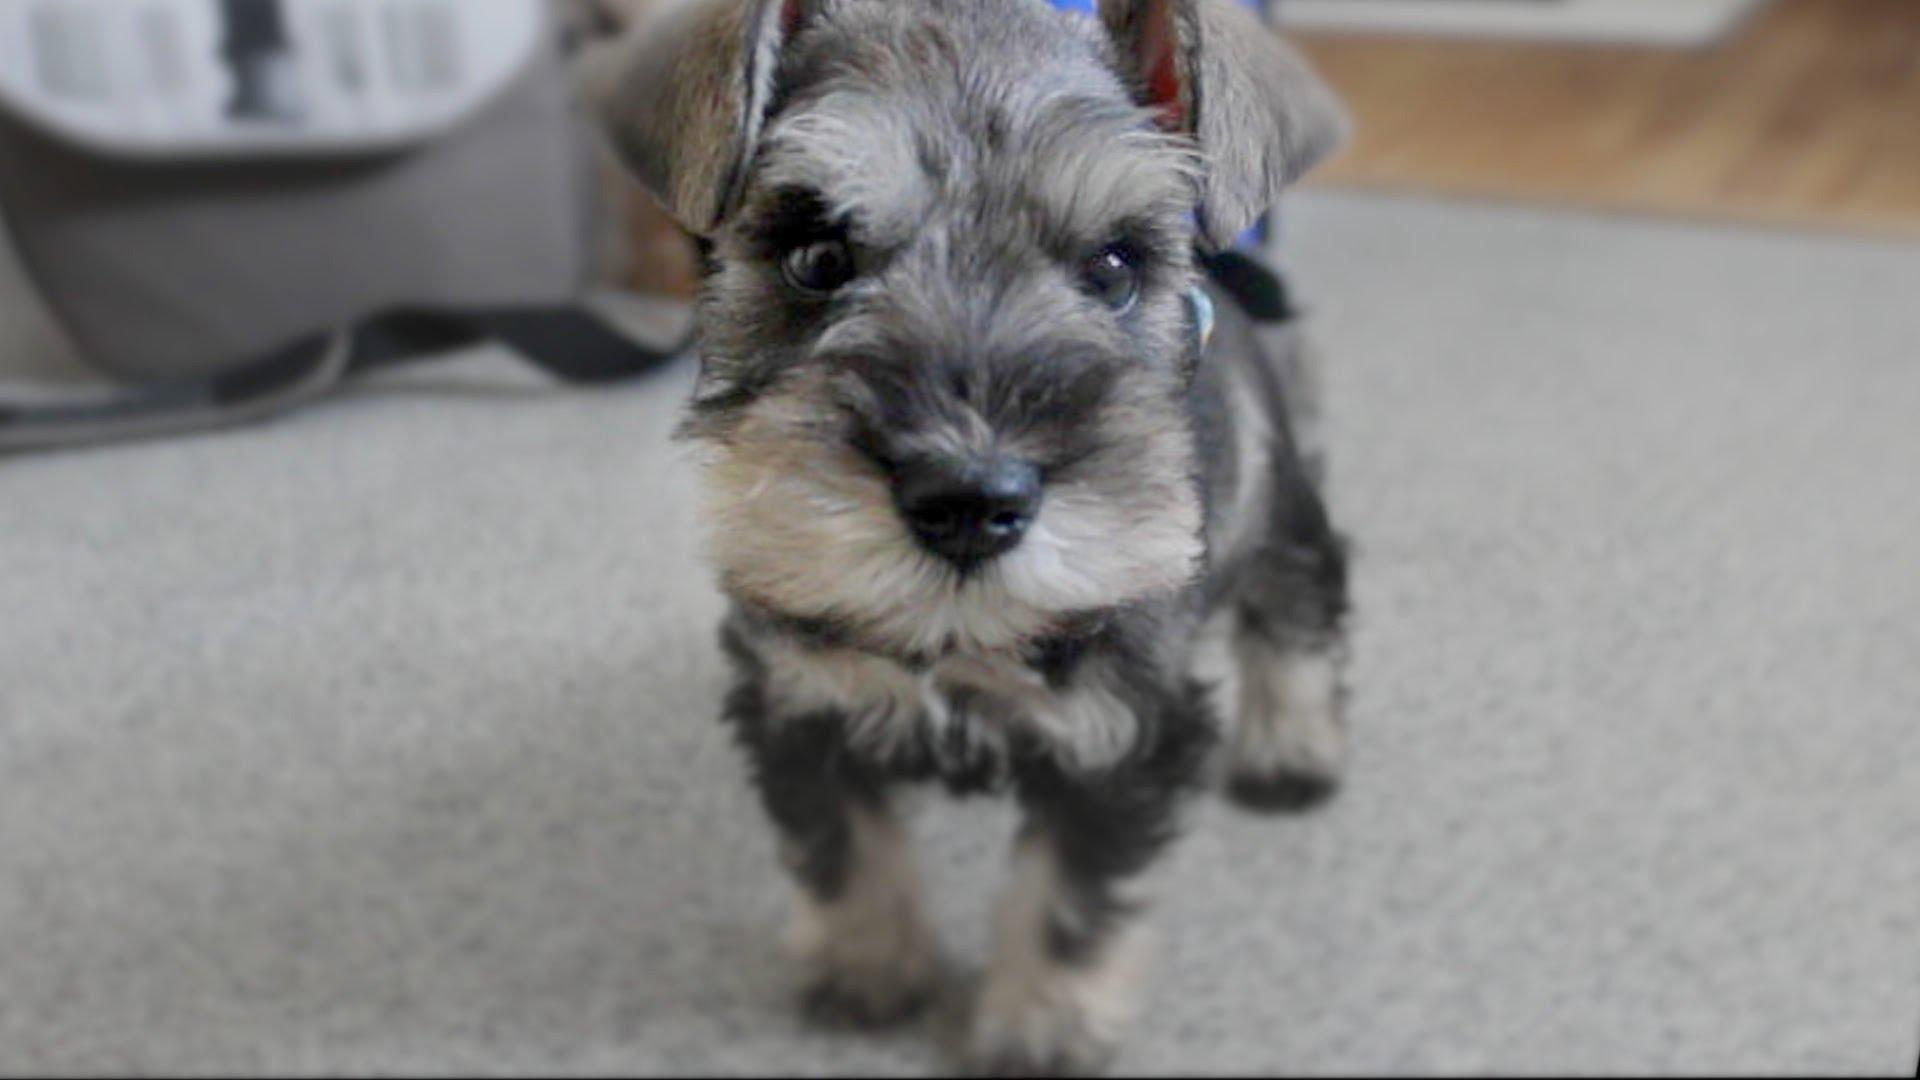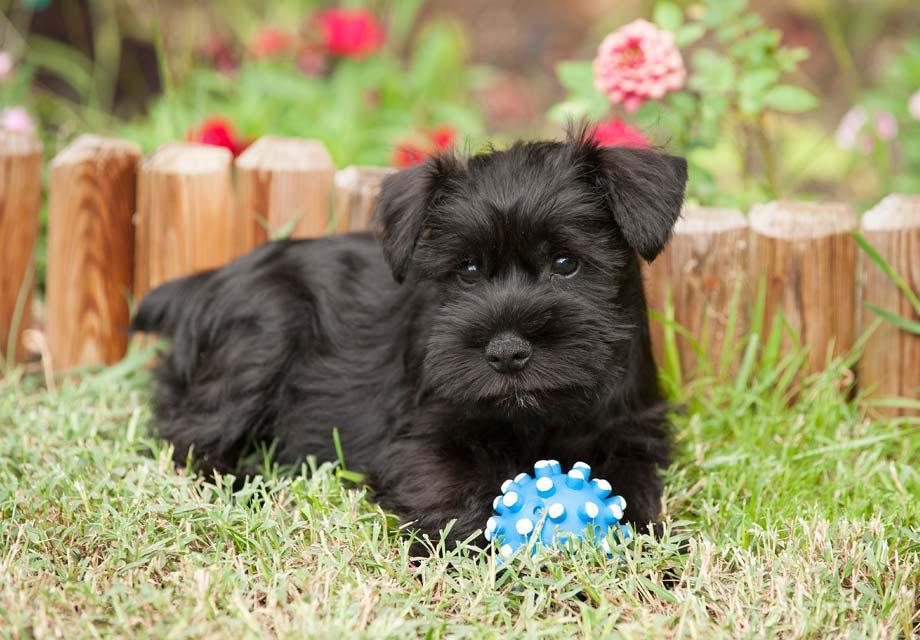The first image is the image on the left, the second image is the image on the right. Given the left and right images, does the statement "An image shows one schnauzer dog on a piece of upholstered furniture, next to a soft object." hold true? Answer yes or no. No. 